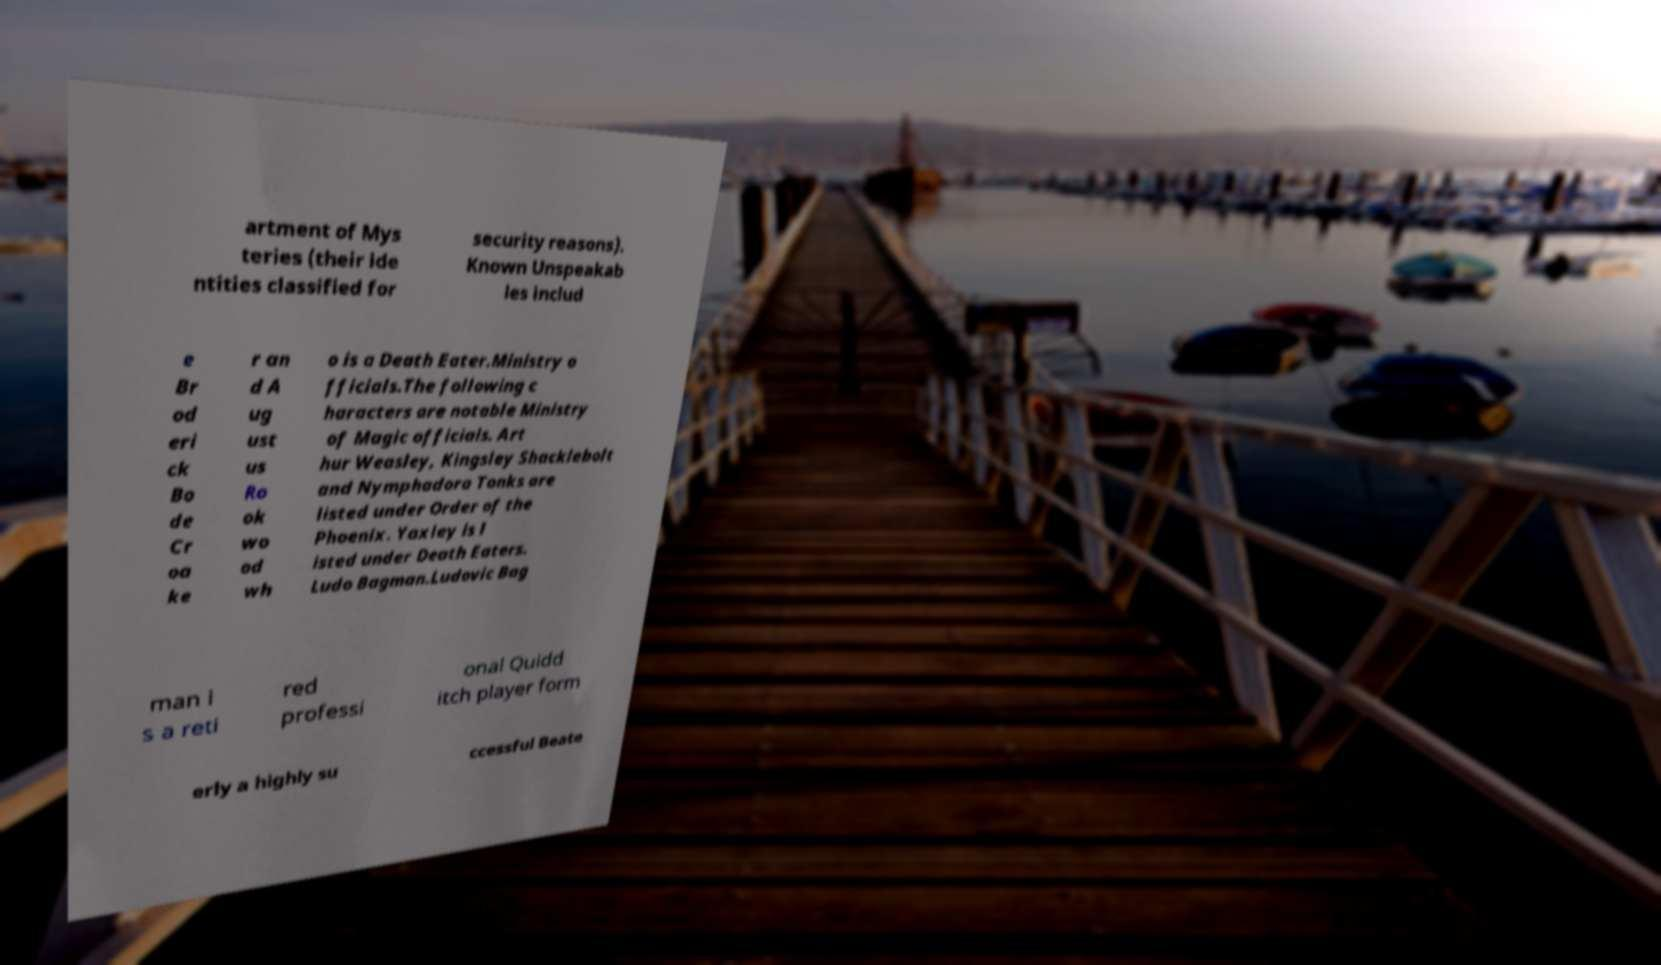I need the written content from this picture converted into text. Can you do that? artment of Mys teries (their ide ntities classified for security reasons). Known Unspeakab les includ e Br od eri ck Bo de Cr oa ke r an d A ug ust us Ro ok wo od wh o is a Death Eater.Ministry o fficials.The following c haracters are notable Ministry of Magic officials. Art hur Weasley, Kingsley Shacklebolt and Nymphadora Tonks are listed under Order of the Phoenix. Yaxley is l isted under Death Eaters. Ludo Bagman.Ludovic Bag man i s a reti red professi onal Quidd itch player form erly a highly su ccessful Beate 